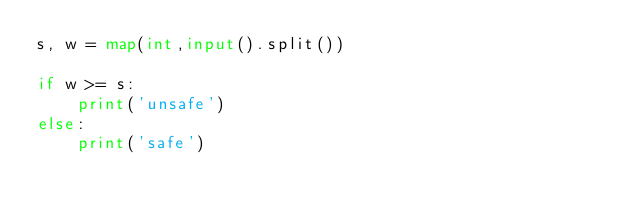<code> <loc_0><loc_0><loc_500><loc_500><_Python_>s, w = map(int,input().split())

if w >= s:
    print('unsafe')
else:
    print('safe')</code> 